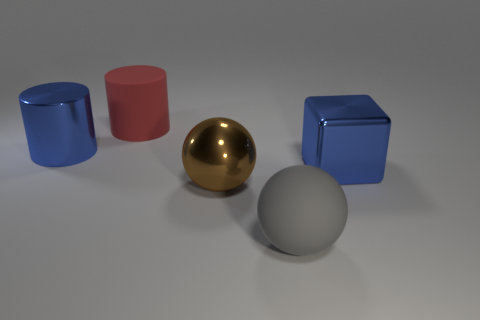What is the size of the object that is the same color as the big metal cube?
Your answer should be compact. Large. Is there a large rubber thing of the same color as the shiny block?
Provide a succinct answer. No. Do the large brown thing and the large gray object have the same material?
Provide a short and direct response. No. How many other things are the same shape as the red matte object?
Ensure brevity in your answer.  1. The big blue thing that is the same material as the large block is what shape?
Offer a very short reply. Cylinder. There is a big matte thing that is in front of the large blue shiny thing that is behind the big blue block; what is its color?
Make the answer very short. Gray. Do the large block and the matte ball have the same color?
Your answer should be very brief. No. What is the blue thing on the left side of the blue object on the right side of the large matte ball made of?
Keep it short and to the point. Metal. There is another big thing that is the same shape as the large red object; what is its material?
Offer a very short reply. Metal. There is a object that is left of the big matte thing behind the big gray rubber ball; are there any large brown metallic things in front of it?
Your answer should be very brief. Yes. 